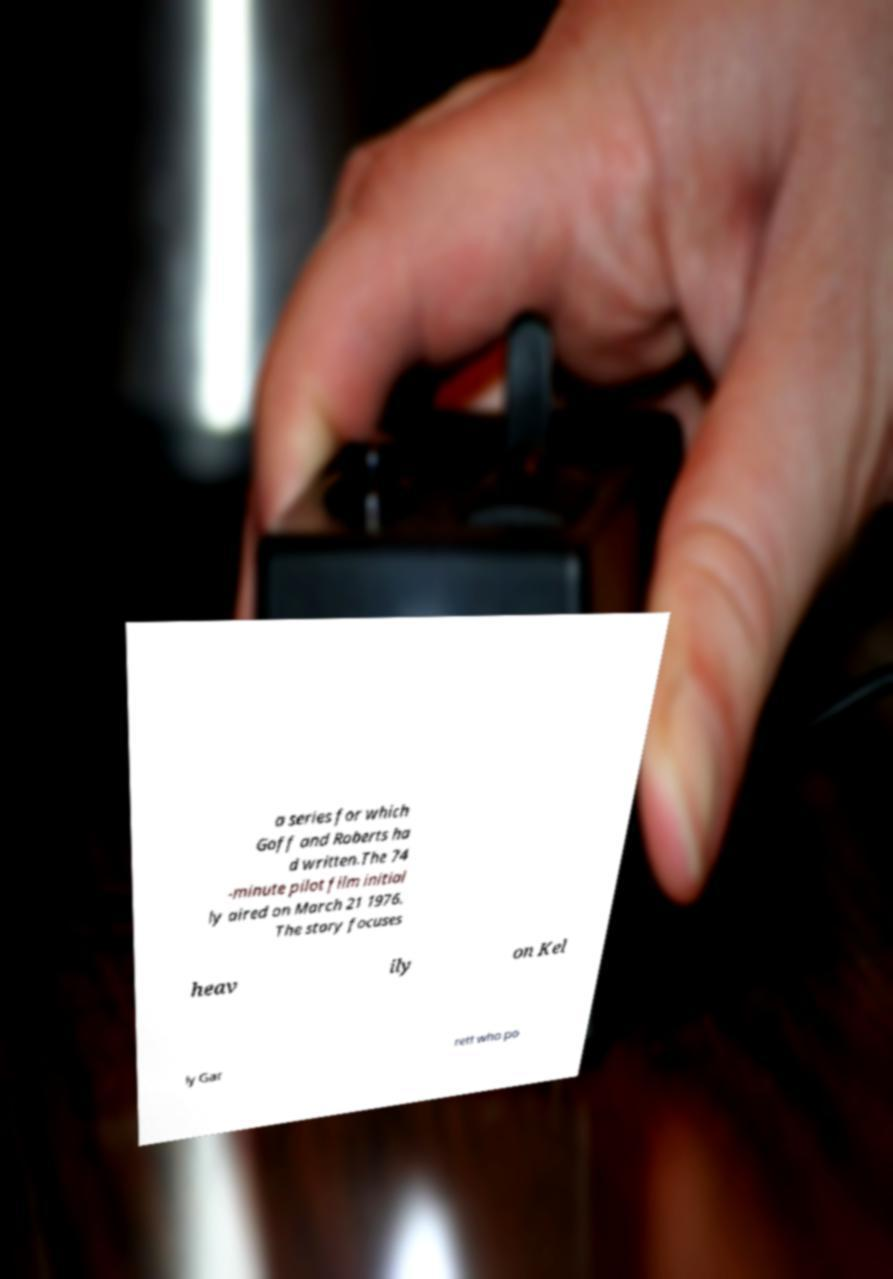What messages or text are displayed in this image? I need them in a readable, typed format. a series for which Goff and Roberts ha d written.The 74 -minute pilot film initial ly aired on March 21 1976. The story focuses heav ily on Kel ly Gar rett who po 